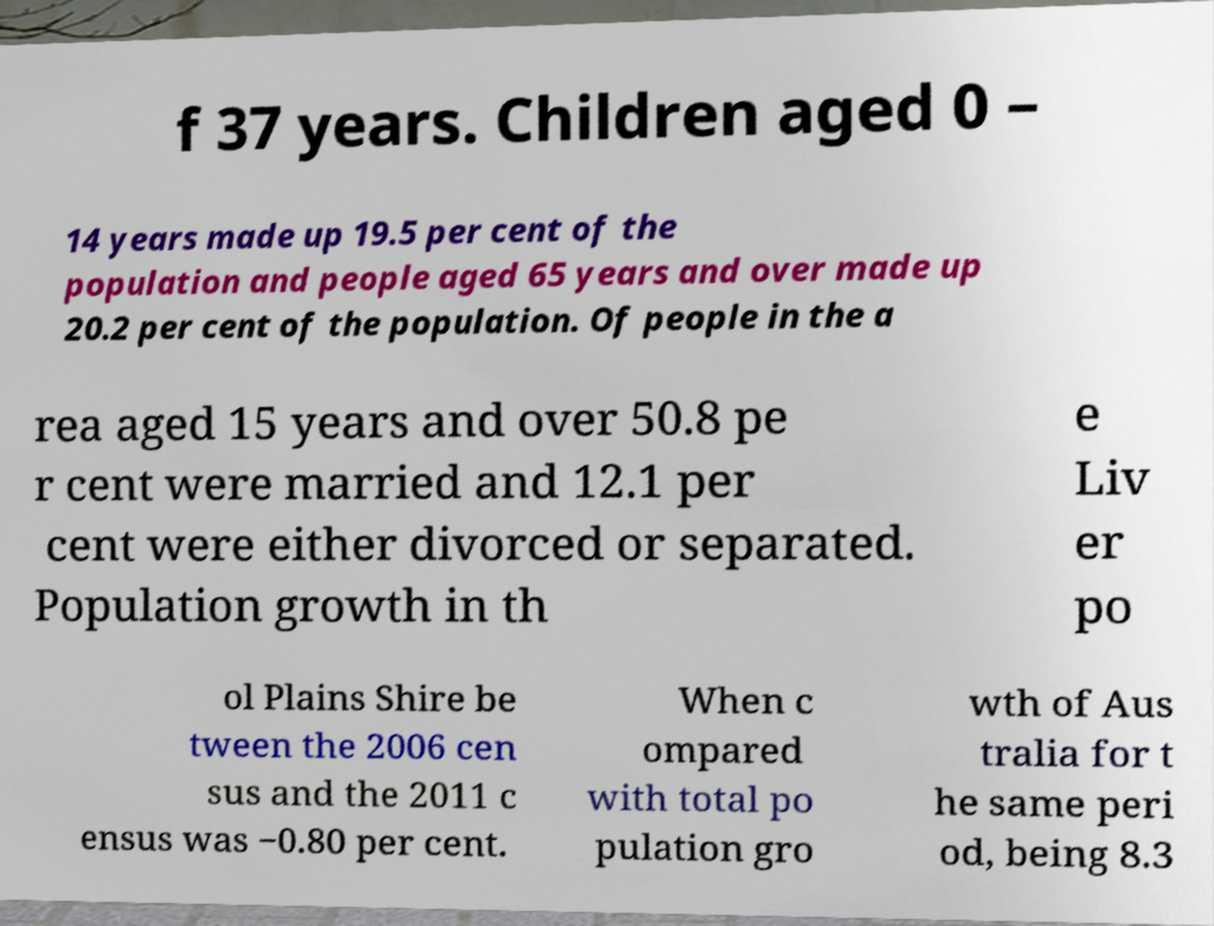Could you assist in decoding the text presented in this image and type it out clearly? f 37 years. Children aged 0 – 14 years made up 19.5 per cent of the population and people aged 65 years and over made up 20.2 per cent of the population. Of people in the a rea aged 15 years and over 50.8 pe r cent were married and 12.1 per cent were either divorced or separated. Population growth in th e Liv er po ol Plains Shire be tween the 2006 cen sus and the 2011 c ensus was −0.80 per cent. When c ompared with total po pulation gro wth of Aus tralia for t he same peri od, being 8.3 